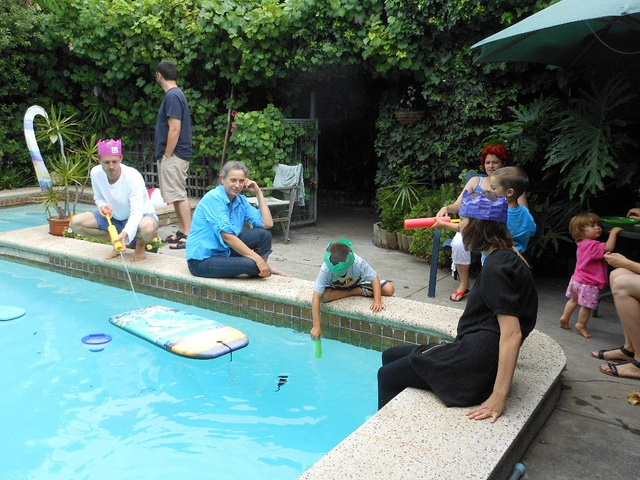Describe the objects in this image and their specific colors. I can see people in olive, black, tan, and gray tones, umbrella in olive, black, lightblue, darkgreen, and teal tones, people in olive, lightblue, blue, and darkblue tones, people in olive, white, darkgray, and gray tones, and potted plant in olive, darkgreen, black, and gray tones in this image. 